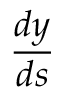<formula> <loc_0><loc_0><loc_500><loc_500>\frac { d y } { d s }</formula> 